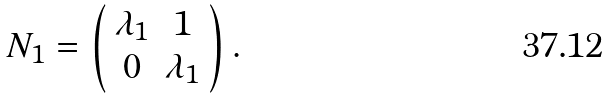Convert formula to latex. <formula><loc_0><loc_0><loc_500><loc_500>N _ { 1 } = \left ( \begin{array} { c c } \lambda _ { 1 } & 1 \\ 0 & \lambda _ { 1 } \end{array} \right ) .</formula> 